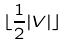Convert formula to latex. <formula><loc_0><loc_0><loc_500><loc_500>\lfloor \frac { 1 } { 2 } | V | \rfloor</formula> 